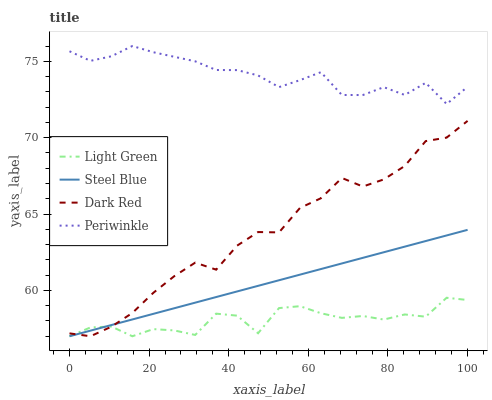Does Light Green have the minimum area under the curve?
Answer yes or no. Yes. Does Periwinkle have the maximum area under the curve?
Answer yes or no. Yes. Does Steel Blue have the minimum area under the curve?
Answer yes or no. No. Does Steel Blue have the maximum area under the curve?
Answer yes or no. No. Is Steel Blue the smoothest?
Answer yes or no. Yes. Is Light Green the roughest?
Answer yes or no. Yes. Is Periwinkle the smoothest?
Answer yes or no. No. Is Periwinkle the roughest?
Answer yes or no. No. Does Dark Red have the lowest value?
Answer yes or no. Yes. Does Periwinkle have the lowest value?
Answer yes or no. No. Does Periwinkle have the highest value?
Answer yes or no. Yes. Does Steel Blue have the highest value?
Answer yes or no. No. Is Steel Blue less than Periwinkle?
Answer yes or no. Yes. Is Periwinkle greater than Light Green?
Answer yes or no. Yes. Does Steel Blue intersect Light Green?
Answer yes or no. Yes. Is Steel Blue less than Light Green?
Answer yes or no. No. Is Steel Blue greater than Light Green?
Answer yes or no. No. Does Steel Blue intersect Periwinkle?
Answer yes or no. No. 